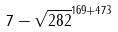<formula> <loc_0><loc_0><loc_500><loc_500>7 - \sqrt { 2 8 2 } ^ { 1 6 9 + 4 7 3 }</formula> 